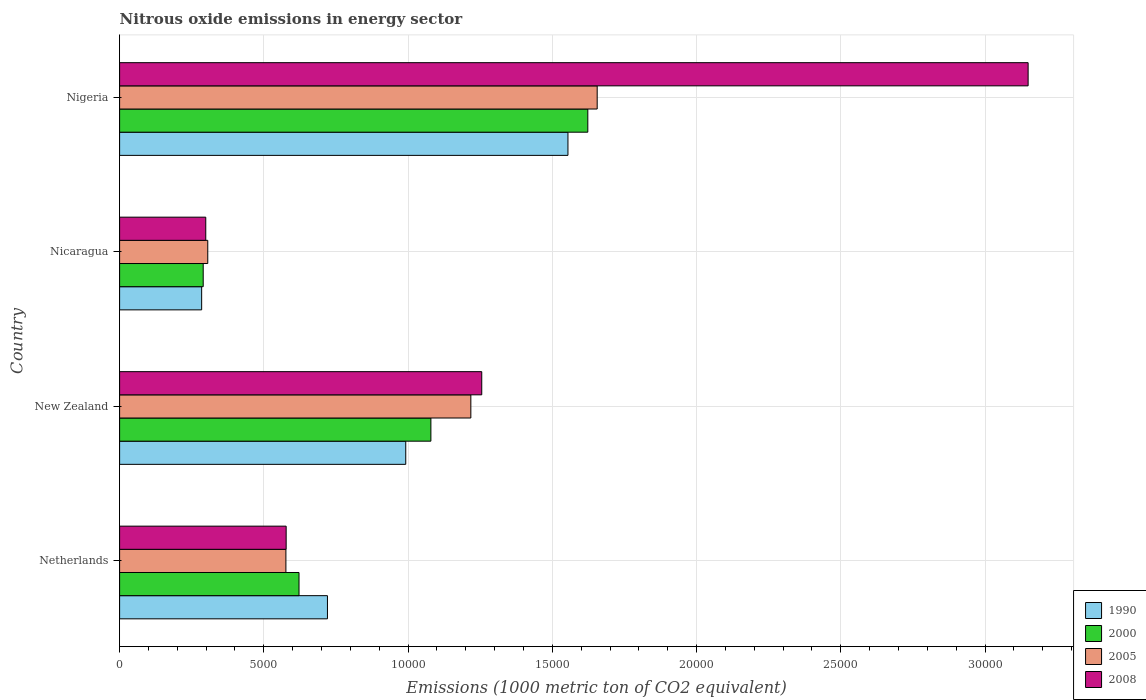How many groups of bars are there?
Offer a terse response. 4. Are the number of bars per tick equal to the number of legend labels?
Offer a terse response. Yes. Are the number of bars on each tick of the Y-axis equal?
Make the answer very short. Yes. How many bars are there on the 3rd tick from the top?
Make the answer very short. 4. How many bars are there on the 3rd tick from the bottom?
Your answer should be compact. 4. What is the label of the 1st group of bars from the top?
Your answer should be very brief. Nigeria. What is the amount of nitrous oxide emitted in 1990 in New Zealand?
Your response must be concise. 9919.5. Across all countries, what is the maximum amount of nitrous oxide emitted in 2000?
Your response must be concise. 1.62e+04. Across all countries, what is the minimum amount of nitrous oxide emitted in 1990?
Your response must be concise. 2844.7. In which country was the amount of nitrous oxide emitted in 2000 maximum?
Offer a very short reply. Nigeria. In which country was the amount of nitrous oxide emitted in 2005 minimum?
Keep it short and to the point. Nicaragua. What is the total amount of nitrous oxide emitted in 2008 in the graph?
Provide a succinct answer. 5.28e+04. What is the difference between the amount of nitrous oxide emitted in 1990 in New Zealand and that in Nigeria?
Your response must be concise. -5623. What is the difference between the amount of nitrous oxide emitted in 2000 in Nicaragua and the amount of nitrous oxide emitted in 2008 in Netherlands?
Your response must be concise. -2875.4. What is the average amount of nitrous oxide emitted in 2008 per country?
Provide a succinct answer. 1.32e+04. What is the difference between the amount of nitrous oxide emitted in 2008 and amount of nitrous oxide emitted in 1990 in Nigeria?
Your response must be concise. 1.60e+04. In how many countries, is the amount of nitrous oxide emitted in 2008 greater than 2000 1000 metric ton?
Offer a terse response. 4. What is the ratio of the amount of nitrous oxide emitted in 2008 in New Zealand to that in Nicaragua?
Give a very brief answer. 4.2. Is the amount of nitrous oxide emitted in 2000 in Netherlands less than that in New Zealand?
Ensure brevity in your answer.  Yes. What is the difference between the highest and the second highest amount of nitrous oxide emitted in 2005?
Give a very brief answer. 4379.5. What is the difference between the highest and the lowest amount of nitrous oxide emitted in 2008?
Keep it short and to the point. 2.85e+04. In how many countries, is the amount of nitrous oxide emitted in 2000 greater than the average amount of nitrous oxide emitted in 2000 taken over all countries?
Give a very brief answer. 2. Is the sum of the amount of nitrous oxide emitted in 1990 in Netherlands and New Zealand greater than the maximum amount of nitrous oxide emitted in 2000 across all countries?
Keep it short and to the point. Yes. What does the 2nd bar from the bottom in Netherlands represents?
Your response must be concise. 2000. Is it the case that in every country, the sum of the amount of nitrous oxide emitted in 2000 and amount of nitrous oxide emitted in 1990 is greater than the amount of nitrous oxide emitted in 2008?
Provide a short and direct response. Yes. What is the difference between two consecutive major ticks on the X-axis?
Offer a terse response. 5000. Does the graph contain any zero values?
Ensure brevity in your answer.  No. Where does the legend appear in the graph?
Provide a short and direct response. Bottom right. How many legend labels are there?
Provide a short and direct response. 4. How are the legend labels stacked?
Your response must be concise. Vertical. What is the title of the graph?
Give a very brief answer. Nitrous oxide emissions in energy sector. Does "1964" appear as one of the legend labels in the graph?
Provide a succinct answer. No. What is the label or title of the X-axis?
Provide a succinct answer. Emissions (1000 metric ton of CO2 equivalent). What is the label or title of the Y-axis?
Offer a terse response. Country. What is the Emissions (1000 metric ton of CO2 equivalent) in 1990 in Netherlands?
Provide a short and direct response. 7205. What is the Emissions (1000 metric ton of CO2 equivalent) of 2000 in Netherlands?
Provide a short and direct response. 6219.5. What is the Emissions (1000 metric ton of CO2 equivalent) in 2005 in Netherlands?
Offer a terse response. 5764.8. What is the Emissions (1000 metric ton of CO2 equivalent) in 2008 in Netherlands?
Make the answer very short. 5773.6. What is the Emissions (1000 metric ton of CO2 equivalent) in 1990 in New Zealand?
Your response must be concise. 9919.5. What is the Emissions (1000 metric ton of CO2 equivalent) in 2000 in New Zealand?
Offer a very short reply. 1.08e+04. What is the Emissions (1000 metric ton of CO2 equivalent) in 2005 in New Zealand?
Ensure brevity in your answer.  1.22e+04. What is the Emissions (1000 metric ton of CO2 equivalent) in 2008 in New Zealand?
Your answer should be very brief. 1.26e+04. What is the Emissions (1000 metric ton of CO2 equivalent) of 1990 in Nicaragua?
Offer a very short reply. 2844.7. What is the Emissions (1000 metric ton of CO2 equivalent) in 2000 in Nicaragua?
Provide a short and direct response. 2898.2. What is the Emissions (1000 metric ton of CO2 equivalent) in 2005 in Nicaragua?
Give a very brief answer. 3056.1. What is the Emissions (1000 metric ton of CO2 equivalent) in 2008 in Nicaragua?
Give a very brief answer. 2986.9. What is the Emissions (1000 metric ton of CO2 equivalent) of 1990 in Nigeria?
Your answer should be very brief. 1.55e+04. What is the Emissions (1000 metric ton of CO2 equivalent) of 2000 in Nigeria?
Your response must be concise. 1.62e+04. What is the Emissions (1000 metric ton of CO2 equivalent) of 2005 in Nigeria?
Keep it short and to the point. 1.66e+04. What is the Emissions (1000 metric ton of CO2 equivalent) of 2008 in Nigeria?
Make the answer very short. 3.15e+04. Across all countries, what is the maximum Emissions (1000 metric ton of CO2 equivalent) in 1990?
Make the answer very short. 1.55e+04. Across all countries, what is the maximum Emissions (1000 metric ton of CO2 equivalent) in 2000?
Offer a terse response. 1.62e+04. Across all countries, what is the maximum Emissions (1000 metric ton of CO2 equivalent) of 2005?
Provide a short and direct response. 1.66e+04. Across all countries, what is the maximum Emissions (1000 metric ton of CO2 equivalent) of 2008?
Provide a succinct answer. 3.15e+04. Across all countries, what is the minimum Emissions (1000 metric ton of CO2 equivalent) in 1990?
Your response must be concise. 2844.7. Across all countries, what is the minimum Emissions (1000 metric ton of CO2 equivalent) of 2000?
Your answer should be very brief. 2898.2. Across all countries, what is the minimum Emissions (1000 metric ton of CO2 equivalent) of 2005?
Provide a short and direct response. 3056.1. Across all countries, what is the minimum Emissions (1000 metric ton of CO2 equivalent) in 2008?
Provide a succinct answer. 2986.9. What is the total Emissions (1000 metric ton of CO2 equivalent) of 1990 in the graph?
Your answer should be very brief. 3.55e+04. What is the total Emissions (1000 metric ton of CO2 equivalent) of 2000 in the graph?
Ensure brevity in your answer.  3.61e+04. What is the total Emissions (1000 metric ton of CO2 equivalent) of 2005 in the graph?
Give a very brief answer. 3.76e+04. What is the total Emissions (1000 metric ton of CO2 equivalent) in 2008 in the graph?
Your answer should be very brief. 5.28e+04. What is the difference between the Emissions (1000 metric ton of CO2 equivalent) of 1990 in Netherlands and that in New Zealand?
Provide a succinct answer. -2714.5. What is the difference between the Emissions (1000 metric ton of CO2 equivalent) in 2000 in Netherlands and that in New Zealand?
Offer a very short reply. -4571.7. What is the difference between the Emissions (1000 metric ton of CO2 equivalent) of 2005 in Netherlands and that in New Zealand?
Provide a succinct answer. -6411.2. What is the difference between the Emissions (1000 metric ton of CO2 equivalent) in 2008 in Netherlands and that in New Zealand?
Your answer should be compact. -6780.5. What is the difference between the Emissions (1000 metric ton of CO2 equivalent) in 1990 in Netherlands and that in Nicaragua?
Your answer should be very brief. 4360.3. What is the difference between the Emissions (1000 metric ton of CO2 equivalent) in 2000 in Netherlands and that in Nicaragua?
Your answer should be compact. 3321.3. What is the difference between the Emissions (1000 metric ton of CO2 equivalent) of 2005 in Netherlands and that in Nicaragua?
Ensure brevity in your answer.  2708.7. What is the difference between the Emissions (1000 metric ton of CO2 equivalent) in 2008 in Netherlands and that in Nicaragua?
Offer a terse response. 2786.7. What is the difference between the Emissions (1000 metric ton of CO2 equivalent) of 1990 in Netherlands and that in Nigeria?
Your answer should be compact. -8337.5. What is the difference between the Emissions (1000 metric ton of CO2 equivalent) of 2000 in Netherlands and that in Nigeria?
Provide a succinct answer. -1.00e+04. What is the difference between the Emissions (1000 metric ton of CO2 equivalent) of 2005 in Netherlands and that in Nigeria?
Offer a terse response. -1.08e+04. What is the difference between the Emissions (1000 metric ton of CO2 equivalent) in 2008 in Netherlands and that in Nigeria?
Offer a terse response. -2.57e+04. What is the difference between the Emissions (1000 metric ton of CO2 equivalent) of 1990 in New Zealand and that in Nicaragua?
Offer a terse response. 7074.8. What is the difference between the Emissions (1000 metric ton of CO2 equivalent) of 2000 in New Zealand and that in Nicaragua?
Ensure brevity in your answer.  7893. What is the difference between the Emissions (1000 metric ton of CO2 equivalent) of 2005 in New Zealand and that in Nicaragua?
Keep it short and to the point. 9119.9. What is the difference between the Emissions (1000 metric ton of CO2 equivalent) of 2008 in New Zealand and that in Nicaragua?
Offer a very short reply. 9567.2. What is the difference between the Emissions (1000 metric ton of CO2 equivalent) in 1990 in New Zealand and that in Nigeria?
Offer a very short reply. -5623. What is the difference between the Emissions (1000 metric ton of CO2 equivalent) in 2000 in New Zealand and that in Nigeria?
Provide a succinct answer. -5439.4. What is the difference between the Emissions (1000 metric ton of CO2 equivalent) in 2005 in New Zealand and that in Nigeria?
Provide a short and direct response. -4379.5. What is the difference between the Emissions (1000 metric ton of CO2 equivalent) in 2008 in New Zealand and that in Nigeria?
Offer a very short reply. -1.89e+04. What is the difference between the Emissions (1000 metric ton of CO2 equivalent) in 1990 in Nicaragua and that in Nigeria?
Make the answer very short. -1.27e+04. What is the difference between the Emissions (1000 metric ton of CO2 equivalent) in 2000 in Nicaragua and that in Nigeria?
Provide a short and direct response. -1.33e+04. What is the difference between the Emissions (1000 metric ton of CO2 equivalent) of 2005 in Nicaragua and that in Nigeria?
Give a very brief answer. -1.35e+04. What is the difference between the Emissions (1000 metric ton of CO2 equivalent) in 2008 in Nicaragua and that in Nigeria?
Provide a short and direct response. -2.85e+04. What is the difference between the Emissions (1000 metric ton of CO2 equivalent) of 1990 in Netherlands and the Emissions (1000 metric ton of CO2 equivalent) of 2000 in New Zealand?
Your answer should be compact. -3586.2. What is the difference between the Emissions (1000 metric ton of CO2 equivalent) in 1990 in Netherlands and the Emissions (1000 metric ton of CO2 equivalent) in 2005 in New Zealand?
Provide a succinct answer. -4971. What is the difference between the Emissions (1000 metric ton of CO2 equivalent) in 1990 in Netherlands and the Emissions (1000 metric ton of CO2 equivalent) in 2008 in New Zealand?
Make the answer very short. -5349.1. What is the difference between the Emissions (1000 metric ton of CO2 equivalent) in 2000 in Netherlands and the Emissions (1000 metric ton of CO2 equivalent) in 2005 in New Zealand?
Provide a succinct answer. -5956.5. What is the difference between the Emissions (1000 metric ton of CO2 equivalent) of 2000 in Netherlands and the Emissions (1000 metric ton of CO2 equivalent) of 2008 in New Zealand?
Your answer should be very brief. -6334.6. What is the difference between the Emissions (1000 metric ton of CO2 equivalent) of 2005 in Netherlands and the Emissions (1000 metric ton of CO2 equivalent) of 2008 in New Zealand?
Your answer should be very brief. -6789.3. What is the difference between the Emissions (1000 metric ton of CO2 equivalent) in 1990 in Netherlands and the Emissions (1000 metric ton of CO2 equivalent) in 2000 in Nicaragua?
Your answer should be compact. 4306.8. What is the difference between the Emissions (1000 metric ton of CO2 equivalent) of 1990 in Netherlands and the Emissions (1000 metric ton of CO2 equivalent) of 2005 in Nicaragua?
Offer a very short reply. 4148.9. What is the difference between the Emissions (1000 metric ton of CO2 equivalent) of 1990 in Netherlands and the Emissions (1000 metric ton of CO2 equivalent) of 2008 in Nicaragua?
Keep it short and to the point. 4218.1. What is the difference between the Emissions (1000 metric ton of CO2 equivalent) in 2000 in Netherlands and the Emissions (1000 metric ton of CO2 equivalent) in 2005 in Nicaragua?
Your answer should be compact. 3163.4. What is the difference between the Emissions (1000 metric ton of CO2 equivalent) of 2000 in Netherlands and the Emissions (1000 metric ton of CO2 equivalent) of 2008 in Nicaragua?
Provide a short and direct response. 3232.6. What is the difference between the Emissions (1000 metric ton of CO2 equivalent) of 2005 in Netherlands and the Emissions (1000 metric ton of CO2 equivalent) of 2008 in Nicaragua?
Give a very brief answer. 2777.9. What is the difference between the Emissions (1000 metric ton of CO2 equivalent) in 1990 in Netherlands and the Emissions (1000 metric ton of CO2 equivalent) in 2000 in Nigeria?
Ensure brevity in your answer.  -9025.6. What is the difference between the Emissions (1000 metric ton of CO2 equivalent) in 1990 in Netherlands and the Emissions (1000 metric ton of CO2 equivalent) in 2005 in Nigeria?
Provide a succinct answer. -9350.5. What is the difference between the Emissions (1000 metric ton of CO2 equivalent) of 1990 in Netherlands and the Emissions (1000 metric ton of CO2 equivalent) of 2008 in Nigeria?
Your answer should be very brief. -2.43e+04. What is the difference between the Emissions (1000 metric ton of CO2 equivalent) in 2000 in Netherlands and the Emissions (1000 metric ton of CO2 equivalent) in 2005 in Nigeria?
Provide a short and direct response. -1.03e+04. What is the difference between the Emissions (1000 metric ton of CO2 equivalent) in 2000 in Netherlands and the Emissions (1000 metric ton of CO2 equivalent) in 2008 in Nigeria?
Give a very brief answer. -2.53e+04. What is the difference between the Emissions (1000 metric ton of CO2 equivalent) in 2005 in Netherlands and the Emissions (1000 metric ton of CO2 equivalent) in 2008 in Nigeria?
Your response must be concise. -2.57e+04. What is the difference between the Emissions (1000 metric ton of CO2 equivalent) of 1990 in New Zealand and the Emissions (1000 metric ton of CO2 equivalent) of 2000 in Nicaragua?
Your response must be concise. 7021.3. What is the difference between the Emissions (1000 metric ton of CO2 equivalent) of 1990 in New Zealand and the Emissions (1000 metric ton of CO2 equivalent) of 2005 in Nicaragua?
Offer a very short reply. 6863.4. What is the difference between the Emissions (1000 metric ton of CO2 equivalent) of 1990 in New Zealand and the Emissions (1000 metric ton of CO2 equivalent) of 2008 in Nicaragua?
Ensure brevity in your answer.  6932.6. What is the difference between the Emissions (1000 metric ton of CO2 equivalent) in 2000 in New Zealand and the Emissions (1000 metric ton of CO2 equivalent) in 2005 in Nicaragua?
Keep it short and to the point. 7735.1. What is the difference between the Emissions (1000 metric ton of CO2 equivalent) of 2000 in New Zealand and the Emissions (1000 metric ton of CO2 equivalent) of 2008 in Nicaragua?
Offer a very short reply. 7804.3. What is the difference between the Emissions (1000 metric ton of CO2 equivalent) of 2005 in New Zealand and the Emissions (1000 metric ton of CO2 equivalent) of 2008 in Nicaragua?
Provide a succinct answer. 9189.1. What is the difference between the Emissions (1000 metric ton of CO2 equivalent) of 1990 in New Zealand and the Emissions (1000 metric ton of CO2 equivalent) of 2000 in Nigeria?
Provide a short and direct response. -6311.1. What is the difference between the Emissions (1000 metric ton of CO2 equivalent) of 1990 in New Zealand and the Emissions (1000 metric ton of CO2 equivalent) of 2005 in Nigeria?
Make the answer very short. -6636. What is the difference between the Emissions (1000 metric ton of CO2 equivalent) of 1990 in New Zealand and the Emissions (1000 metric ton of CO2 equivalent) of 2008 in Nigeria?
Offer a very short reply. -2.16e+04. What is the difference between the Emissions (1000 metric ton of CO2 equivalent) of 2000 in New Zealand and the Emissions (1000 metric ton of CO2 equivalent) of 2005 in Nigeria?
Your answer should be compact. -5764.3. What is the difference between the Emissions (1000 metric ton of CO2 equivalent) in 2000 in New Zealand and the Emissions (1000 metric ton of CO2 equivalent) in 2008 in Nigeria?
Your response must be concise. -2.07e+04. What is the difference between the Emissions (1000 metric ton of CO2 equivalent) in 2005 in New Zealand and the Emissions (1000 metric ton of CO2 equivalent) in 2008 in Nigeria?
Your answer should be very brief. -1.93e+04. What is the difference between the Emissions (1000 metric ton of CO2 equivalent) in 1990 in Nicaragua and the Emissions (1000 metric ton of CO2 equivalent) in 2000 in Nigeria?
Make the answer very short. -1.34e+04. What is the difference between the Emissions (1000 metric ton of CO2 equivalent) of 1990 in Nicaragua and the Emissions (1000 metric ton of CO2 equivalent) of 2005 in Nigeria?
Your answer should be very brief. -1.37e+04. What is the difference between the Emissions (1000 metric ton of CO2 equivalent) of 1990 in Nicaragua and the Emissions (1000 metric ton of CO2 equivalent) of 2008 in Nigeria?
Keep it short and to the point. -2.86e+04. What is the difference between the Emissions (1000 metric ton of CO2 equivalent) of 2000 in Nicaragua and the Emissions (1000 metric ton of CO2 equivalent) of 2005 in Nigeria?
Provide a short and direct response. -1.37e+04. What is the difference between the Emissions (1000 metric ton of CO2 equivalent) of 2000 in Nicaragua and the Emissions (1000 metric ton of CO2 equivalent) of 2008 in Nigeria?
Make the answer very short. -2.86e+04. What is the difference between the Emissions (1000 metric ton of CO2 equivalent) in 2005 in Nicaragua and the Emissions (1000 metric ton of CO2 equivalent) in 2008 in Nigeria?
Give a very brief answer. -2.84e+04. What is the average Emissions (1000 metric ton of CO2 equivalent) of 1990 per country?
Your answer should be very brief. 8877.92. What is the average Emissions (1000 metric ton of CO2 equivalent) in 2000 per country?
Offer a terse response. 9034.88. What is the average Emissions (1000 metric ton of CO2 equivalent) in 2005 per country?
Your answer should be very brief. 9388.1. What is the average Emissions (1000 metric ton of CO2 equivalent) of 2008 per country?
Your response must be concise. 1.32e+04. What is the difference between the Emissions (1000 metric ton of CO2 equivalent) of 1990 and Emissions (1000 metric ton of CO2 equivalent) of 2000 in Netherlands?
Your answer should be compact. 985.5. What is the difference between the Emissions (1000 metric ton of CO2 equivalent) of 1990 and Emissions (1000 metric ton of CO2 equivalent) of 2005 in Netherlands?
Keep it short and to the point. 1440.2. What is the difference between the Emissions (1000 metric ton of CO2 equivalent) of 1990 and Emissions (1000 metric ton of CO2 equivalent) of 2008 in Netherlands?
Provide a succinct answer. 1431.4. What is the difference between the Emissions (1000 metric ton of CO2 equivalent) in 2000 and Emissions (1000 metric ton of CO2 equivalent) in 2005 in Netherlands?
Keep it short and to the point. 454.7. What is the difference between the Emissions (1000 metric ton of CO2 equivalent) of 2000 and Emissions (1000 metric ton of CO2 equivalent) of 2008 in Netherlands?
Provide a succinct answer. 445.9. What is the difference between the Emissions (1000 metric ton of CO2 equivalent) in 1990 and Emissions (1000 metric ton of CO2 equivalent) in 2000 in New Zealand?
Offer a very short reply. -871.7. What is the difference between the Emissions (1000 metric ton of CO2 equivalent) of 1990 and Emissions (1000 metric ton of CO2 equivalent) of 2005 in New Zealand?
Ensure brevity in your answer.  -2256.5. What is the difference between the Emissions (1000 metric ton of CO2 equivalent) in 1990 and Emissions (1000 metric ton of CO2 equivalent) in 2008 in New Zealand?
Your response must be concise. -2634.6. What is the difference between the Emissions (1000 metric ton of CO2 equivalent) in 2000 and Emissions (1000 metric ton of CO2 equivalent) in 2005 in New Zealand?
Provide a short and direct response. -1384.8. What is the difference between the Emissions (1000 metric ton of CO2 equivalent) in 2000 and Emissions (1000 metric ton of CO2 equivalent) in 2008 in New Zealand?
Your response must be concise. -1762.9. What is the difference between the Emissions (1000 metric ton of CO2 equivalent) in 2005 and Emissions (1000 metric ton of CO2 equivalent) in 2008 in New Zealand?
Your response must be concise. -378.1. What is the difference between the Emissions (1000 metric ton of CO2 equivalent) of 1990 and Emissions (1000 metric ton of CO2 equivalent) of 2000 in Nicaragua?
Make the answer very short. -53.5. What is the difference between the Emissions (1000 metric ton of CO2 equivalent) of 1990 and Emissions (1000 metric ton of CO2 equivalent) of 2005 in Nicaragua?
Ensure brevity in your answer.  -211.4. What is the difference between the Emissions (1000 metric ton of CO2 equivalent) of 1990 and Emissions (1000 metric ton of CO2 equivalent) of 2008 in Nicaragua?
Give a very brief answer. -142.2. What is the difference between the Emissions (1000 metric ton of CO2 equivalent) of 2000 and Emissions (1000 metric ton of CO2 equivalent) of 2005 in Nicaragua?
Your answer should be compact. -157.9. What is the difference between the Emissions (1000 metric ton of CO2 equivalent) in 2000 and Emissions (1000 metric ton of CO2 equivalent) in 2008 in Nicaragua?
Keep it short and to the point. -88.7. What is the difference between the Emissions (1000 metric ton of CO2 equivalent) of 2005 and Emissions (1000 metric ton of CO2 equivalent) of 2008 in Nicaragua?
Ensure brevity in your answer.  69.2. What is the difference between the Emissions (1000 metric ton of CO2 equivalent) of 1990 and Emissions (1000 metric ton of CO2 equivalent) of 2000 in Nigeria?
Give a very brief answer. -688.1. What is the difference between the Emissions (1000 metric ton of CO2 equivalent) in 1990 and Emissions (1000 metric ton of CO2 equivalent) in 2005 in Nigeria?
Make the answer very short. -1013. What is the difference between the Emissions (1000 metric ton of CO2 equivalent) of 1990 and Emissions (1000 metric ton of CO2 equivalent) of 2008 in Nigeria?
Make the answer very short. -1.60e+04. What is the difference between the Emissions (1000 metric ton of CO2 equivalent) in 2000 and Emissions (1000 metric ton of CO2 equivalent) in 2005 in Nigeria?
Your answer should be compact. -324.9. What is the difference between the Emissions (1000 metric ton of CO2 equivalent) in 2000 and Emissions (1000 metric ton of CO2 equivalent) in 2008 in Nigeria?
Make the answer very short. -1.53e+04. What is the difference between the Emissions (1000 metric ton of CO2 equivalent) of 2005 and Emissions (1000 metric ton of CO2 equivalent) of 2008 in Nigeria?
Offer a very short reply. -1.49e+04. What is the ratio of the Emissions (1000 metric ton of CO2 equivalent) of 1990 in Netherlands to that in New Zealand?
Give a very brief answer. 0.73. What is the ratio of the Emissions (1000 metric ton of CO2 equivalent) in 2000 in Netherlands to that in New Zealand?
Your answer should be very brief. 0.58. What is the ratio of the Emissions (1000 metric ton of CO2 equivalent) of 2005 in Netherlands to that in New Zealand?
Offer a terse response. 0.47. What is the ratio of the Emissions (1000 metric ton of CO2 equivalent) in 2008 in Netherlands to that in New Zealand?
Provide a short and direct response. 0.46. What is the ratio of the Emissions (1000 metric ton of CO2 equivalent) of 1990 in Netherlands to that in Nicaragua?
Keep it short and to the point. 2.53. What is the ratio of the Emissions (1000 metric ton of CO2 equivalent) of 2000 in Netherlands to that in Nicaragua?
Offer a very short reply. 2.15. What is the ratio of the Emissions (1000 metric ton of CO2 equivalent) of 2005 in Netherlands to that in Nicaragua?
Offer a terse response. 1.89. What is the ratio of the Emissions (1000 metric ton of CO2 equivalent) in 2008 in Netherlands to that in Nicaragua?
Offer a very short reply. 1.93. What is the ratio of the Emissions (1000 metric ton of CO2 equivalent) of 1990 in Netherlands to that in Nigeria?
Offer a terse response. 0.46. What is the ratio of the Emissions (1000 metric ton of CO2 equivalent) in 2000 in Netherlands to that in Nigeria?
Offer a very short reply. 0.38. What is the ratio of the Emissions (1000 metric ton of CO2 equivalent) of 2005 in Netherlands to that in Nigeria?
Keep it short and to the point. 0.35. What is the ratio of the Emissions (1000 metric ton of CO2 equivalent) in 2008 in Netherlands to that in Nigeria?
Make the answer very short. 0.18. What is the ratio of the Emissions (1000 metric ton of CO2 equivalent) of 1990 in New Zealand to that in Nicaragua?
Provide a short and direct response. 3.49. What is the ratio of the Emissions (1000 metric ton of CO2 equivalent) in 2000 in New Zealand to that in Nicaragua?
Offer a terse response. 3.72. What is the ratio of the Emissions (1000 metric ton of CO2 equivalent) in 2005 in New Zealand to that in Nicaragua?
Offer a very short reply. 3.98. What is the ratio of the Emissions (1000 metric ton of CO2 equivalent) in 2008 in New Zealand to that in Nicaragua?
Provide a short and direct response. 4.2. What is the ratio of the Emissions (1000 metric ton of CO2 equivalent) in 1990 in New Zealand to that in Nigeria?
Your answer should be very brief. 0.64. What is the ratio of the Emissions (1000 metric ton of CO2 equivalent) of 2000 in New Zealand to that in Nigeria?
Your response must be concise. 0.66. What is the ratio of the Emissions (1000 metric ton of CO2 equivalent) of 2005 in New Zealand to that in Nigeria?
Offer a very short reply. 0.74. What is the ratio of the Emissions (1000 metric ton of CO2 equivalent) in 2008 in New Zealand to that in Nigeria?
Provide a short and direct response. 0.4. What is the ratio of the Emissions (1000 metric ton of CO2 equivalent) in 1990 in Nicaragua to that in Nigeria?
Offer a terse response. 0.18. What is the ratio of the Emissions (1000 metric ton of CO2 equivalent) of 2000 in Nicaragua to that in Nigeria?
Provide a succinct answer. 0.18. What is the ratio of the Emissions (1000 metric ton of CO2 equivalent) of 2005 in Nicaragua to that in Nigeria?
Keep it short and to the point. 0.18. What is the ratio of the Emissions (1000 metric ton of CO2 equivalent) in 2008 in Nicaragua to that in Nigeria?
Your response must be concise. 0.09. What is the difference between the highest and the second highest Emissions (1000 metric ton of CO2 equivalent) of 1990?
Your response must be concise. 5623. What is the difference between the highest and the second highest Emissions (1000 metric ton of CO2 equivalent) in 2000?
Ensure brevity in your answer.  5439.4. What is the difference between the highest and the second highest Emissions (1000 metric ton of CO2 equivalent) in 2005?
Your answer should be very brief. 4379.5. What is the difference between the highest and the second highest Emissions (1000 metric ton of CO2 equivalent) of 2008?
Provide a short and direct response. 1.89e+04. What is the difference between the highest and the lowest Emissions (1000 metric ton of CO2 equivalent) in 1990?
Offer a very short reply. 1.27e+04. What is the difference between the highest and the lowest Emissions (1000 metric ton of CO2 equivalent) of 2000?
Provide a succinct answer. 1.33e+04. What is the difference between the highest and the lowest Emissions (1000 metric ton of CO2 equivalent) in 2005?
Offer a very short reply. 1.35e+04. What is the difference between the highest and the lowest Emissions (1000 metric ton of CO2 equivalent) in 2008?
Provide a short and direct response. 2.85e+04. 